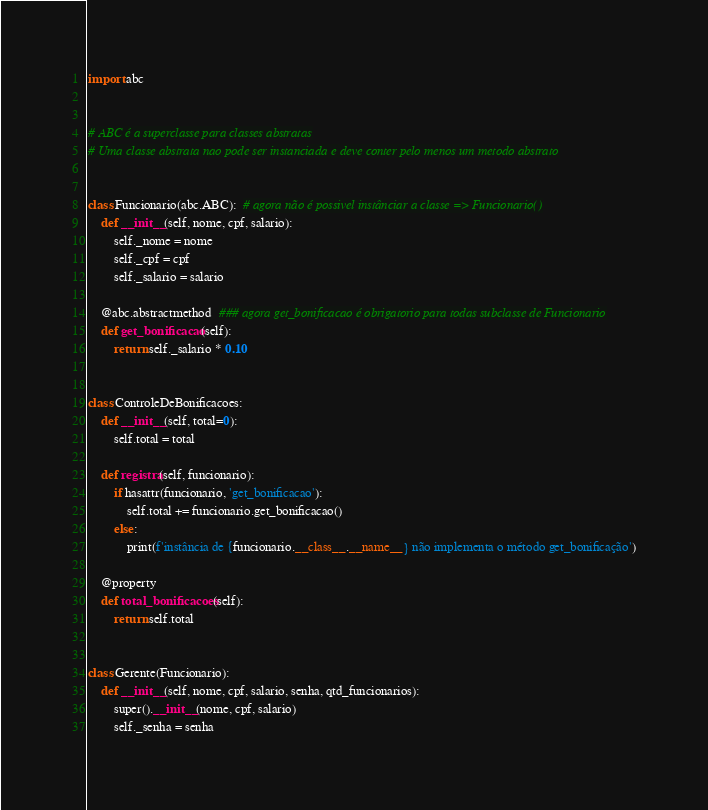Convert code to text. <code><loc_0><loc_0><loc_500><loc_500><_Python_>import abc


# ABC é a superclasse para classes abstratas
# Uma classe abstrata nao pode ser instanciada e deve conter pelo menos um metodo abstrato


class Funcionario(abc.ABC):  # agora não é possivel instânciar a classe => Funcionario()
    def __init__(self, nome, cpf, salario):
        self._nome = nome
        self._cpf = cpf
        self._salario = salario

    @abc.abstractmethod  ### agora get_bonificacao é obrigatorio para todas subclasse de Funcionario
    def get_bonificacao(self):
        return self._salario * 0.10


class ControleDeBonificacoes:
    def __init__(self, total=0):
        self.total = total

    def registra(self, funcionario):
        if hasattr(funcionario, 'get_bonificacao'):
            self.total += funcionario.get_bonificacao()
        else:
            print(f'instância de {funcionario.__class__.__name__} não implementa o método get_bonificação')

    @property
    def total_bonificacoes(self):
        return self.total


class Gerente(Funcionario):
    def __init__(self, nome, cpf, salario, senha, qtd_funcionarios):
        super().__init__(nome, cpf, salario)
        self._senha = senha</code> 